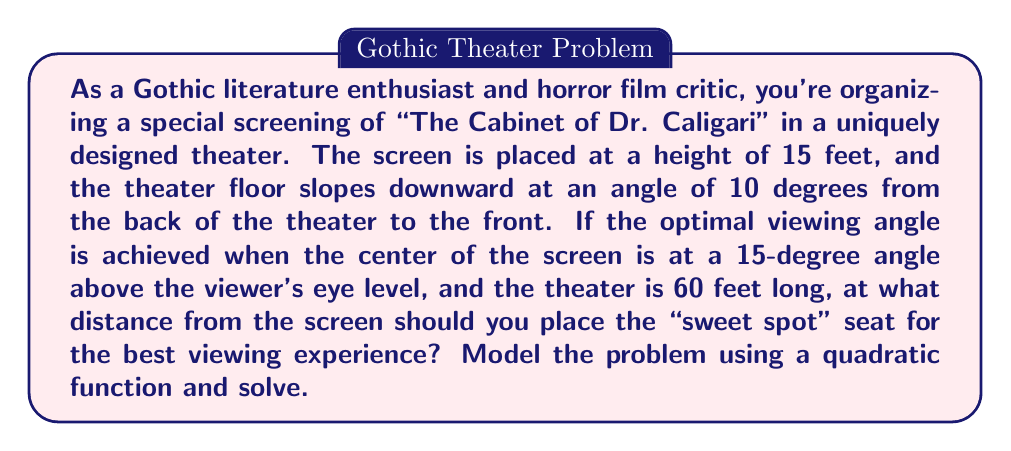Show me your answer to this math problem. Let's approach this step-by-step:

1) First, let's define our coordinate system. Let the origin (0,0) be at the base of the screen, with x representing the horizontal distance from the screen, and y representing the height.

2) We can model the theater floor with a linear function:
   $y = -\tan(10°) \cdot x + 15$
   (The slope is negative because the floor goes down as x increases)

3) The line of sight to the center of the screen can be modeled with another linear function:
   $y = \tan(15°) \cdot x$

4) The optimal viewing point is where these two lines intersect. We can find this by setting them equal:

   $-\tan(10°) \cdot x + 15 = \tan(15°) \cdot x$

5) Solving for x:
   $x(\tan(15°) + \tan(10°)) = 15$
   $x = \frac{15}{\tan(15°) + \tan(10°)}$

6) Using a calculator or programming language to evaluate this:
   $x \approx 39.34$ feet

7) To verify this is indeed the optimal point, we can model the viewing angle as a function of distance from the screen:

   $\theta(x) = \arctan(\frac{15}{x}) - \arctan(\frac{\tan(10°) \cdot x - 15}{x})$

8) This function reaches its maximum when $\theta(x) = 15°$, which occurs at our calculated x value.

9) We can visualize this with a graph:

[asy]
import graph;
size(200,200);
real f(real x) {return -tan(10*pi/180)*x + 15;}
real g(real x) {return tan(15*pi/180)*x;}
real h(real x) {return atan(15/x) - atan((tan(10*pi/180)*x - 15)/x)*180/pi;}
draw(graph(f,0,60));
draw(graph(g,0,60),dashed);
draw(graph(h,1,60),red);
ylimits(0,20);
xaxis("Distance from screen (feet)",Ticks);
yaxis("Height (feet) / Angle (degrees)",Ticks);
label("Theater floor",(-2,16));
label("Line of sight",(-2,3));
label("Viewing angle",(50,18),red);
dot((39.34,f(39.34)));
label("Optimal point",(39.34,f(39.34)),SE);
[/asy]
Answer: The optimal viewing distance from the screen is approximately 39.34 feet. 